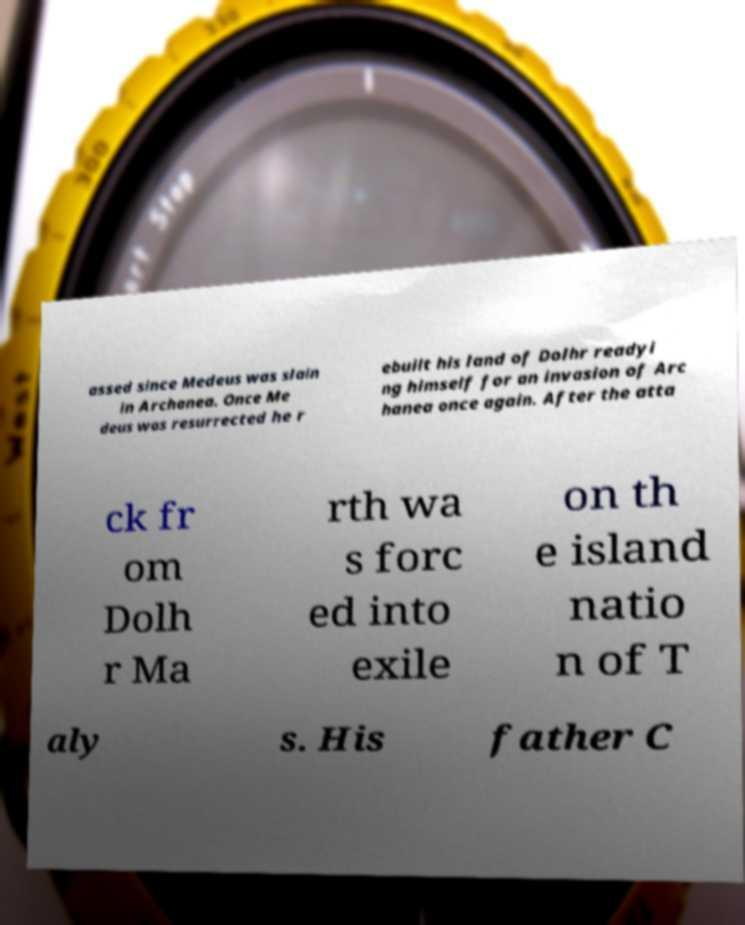Can you accurately transcribe the text from the provided image for me? assed since Medeus was slain in Archanea. Once Me deus was resurrected he r ebuilt his land of Dolhr readyi ng himself for an invasion of Arc hanea once again. After the atta ck fr om Dolh r Ma rth wa s forc ed into exile on th e island natio n of T aly s. His father C 